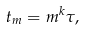Convert formula to latex. <formula><loc_0><loc_0><loc_500><loc_500>t _ { m } = m ^ { k } \tau ,</formula> 